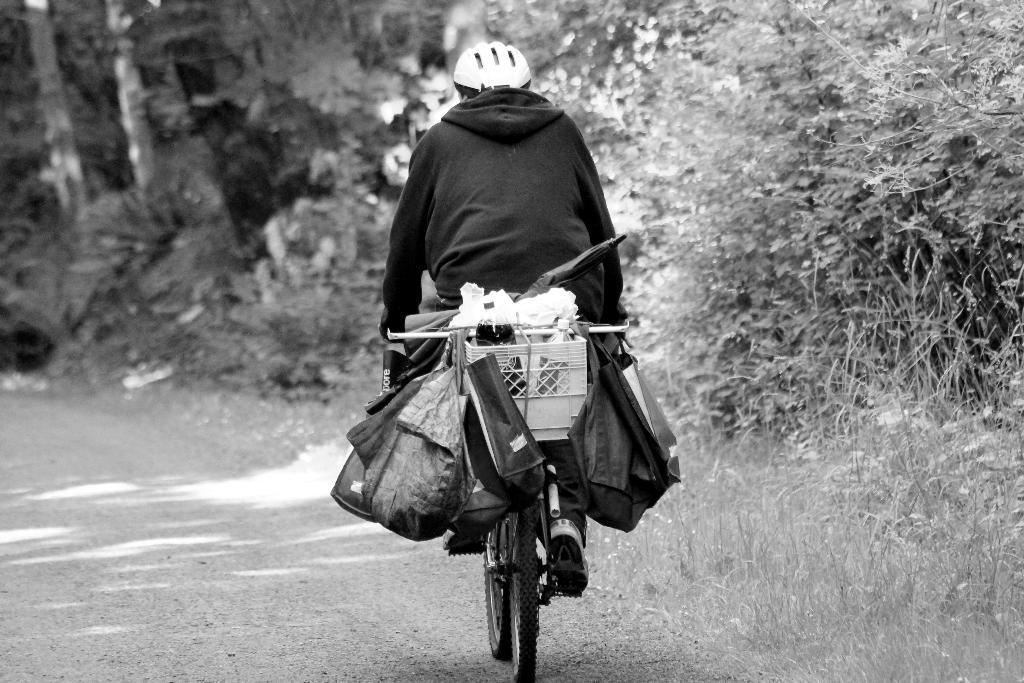Describe this image in one or two sentences. In this image there is a person riding a bicycle on the path, on the bicycle there are few objects and bags are hanging. On the right side of the image there are trees and grass. 